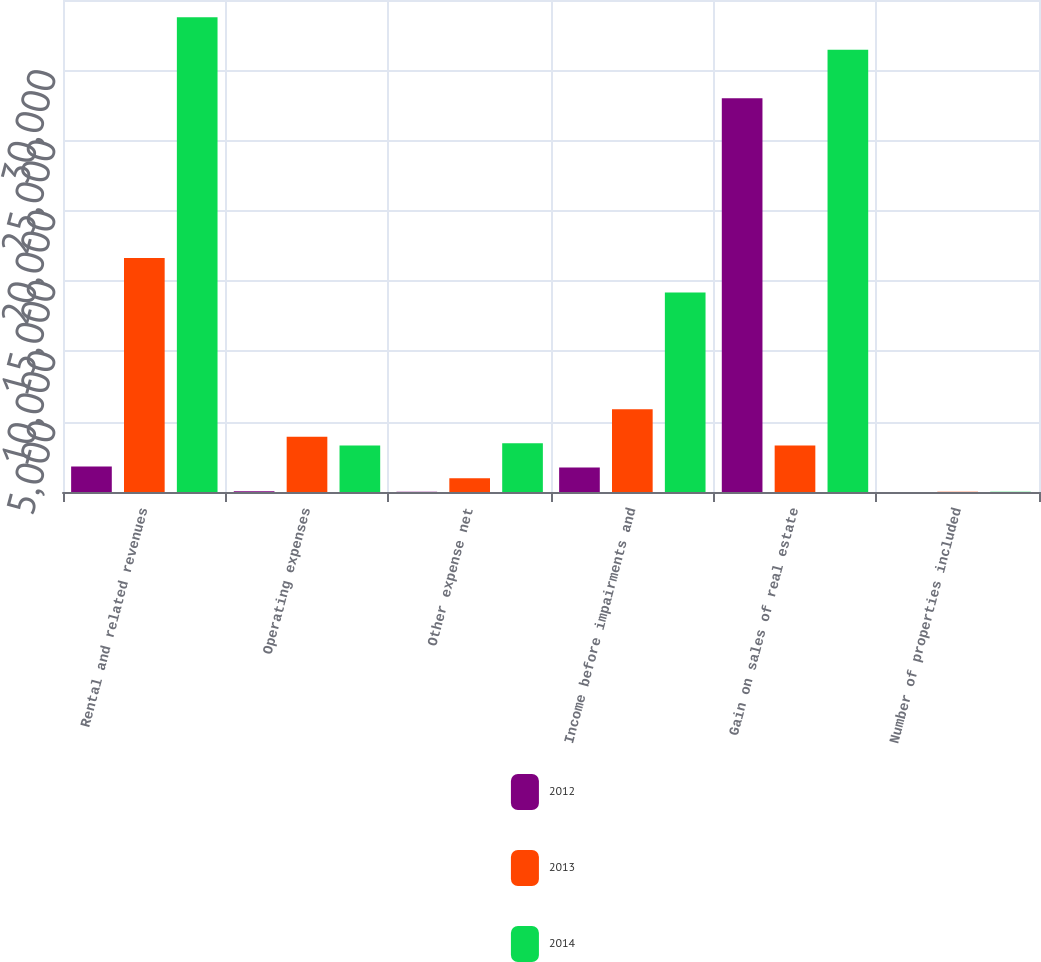Convert chart to OTSL. <chart><loc_0><loc_0><loc_500><loc_500><stacked_bar_chart><ecel><fcel>Rental and related revenues<fcel>Operating expenses<fcel>Other expense net<fcel>Income before impairments and<fcel>Gain on sales of real estate<fcel>Number of properties included<nl><fcel>2012<fcel>1810<fcel>54<fcel>20<fcel>1736<fcel>28010<fcel>3<nl><fcel>2013<fcel>16649<fcel>3929<fcel>979<fcel>5879<fcel>3304<fcel>16<nl><fcel>2014<fcel>33777<fcel>3304<fcel>3467<fcel>14198<fcel>31454<fcel>20<nl></chart> 